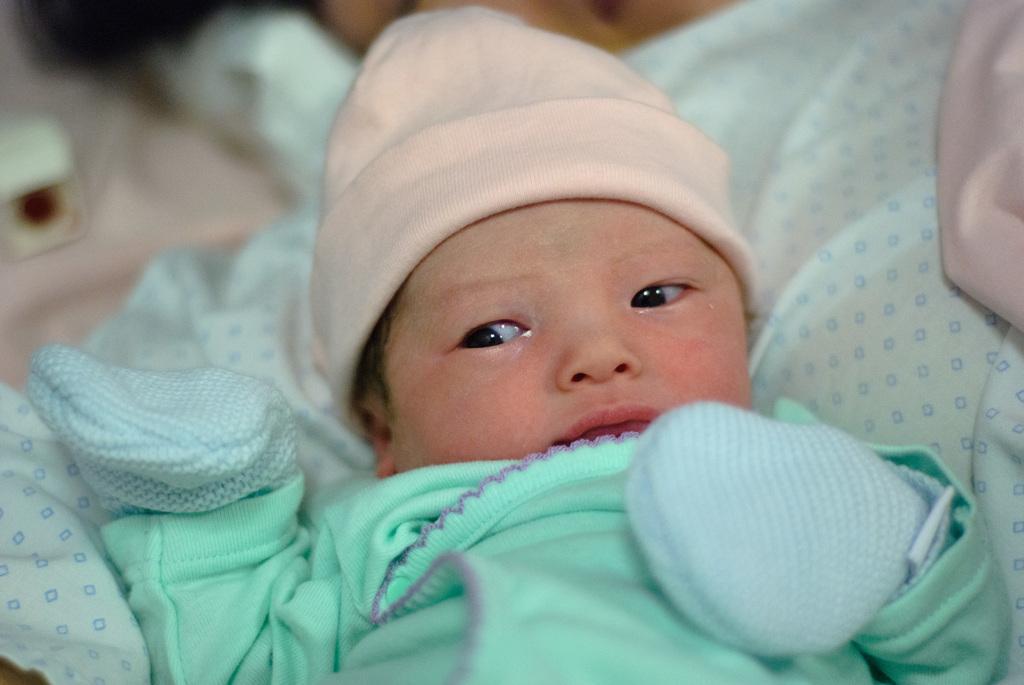In one or two sentences, can you explain what this image depicts? In this picture we can see a baby wearing gloves,cap and in the background we can see a cloth. 